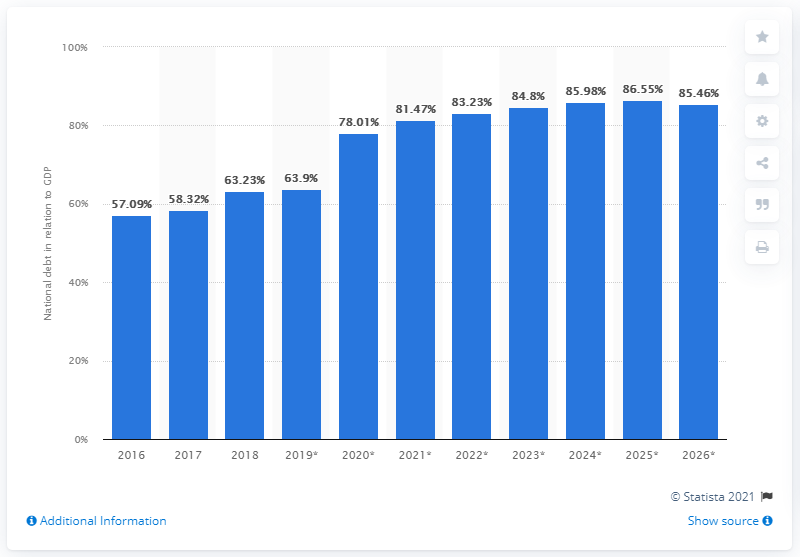Specify some key components in this picture. The national debt of Ghana in 2018 was $63.23 billion. 